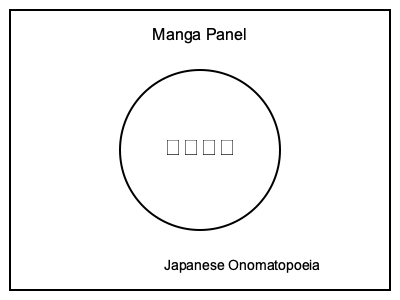In the manga panel above, how would you translate the Japanese onomatopoeia "ドキドキ" (doki doki) to effectively convey its meaning and visual impact in English? To translate Japanese onomatopoeia in manga panels, follow these steps:

1. Identify the meaning: "ドキドキ" (doki doki) represents a heart pounding or racing, often due to excitement, nervousness, or anticipation.

2. Consider the context: Without additional context, assume this is a general representation of a character's emotional state.

3. Evaluate translation options:
   a) Literal transliteration: "Doki doki"
   b) English equivalent sound: "Thump thump"
   c) Descriptive phrase: "Heart racing"

4. Assess visual impact: The onomatopoeia is placed inside a circle, likely representing a heart or emphasizing the sound's importance.

5. Choose the best option: "Thump thump" effectively conveys both the sound and meaning while maintaining a similar visual structure to the original.

6. Consider visual adaptation: Retain the circular shape and possibly add heartbeat lines for enhanced effect.

7. Ensure consistency: If this onomatopoeia appears frequently, maintain the same translation throughout the manga for reader clarity.
Answer: Thump thump 